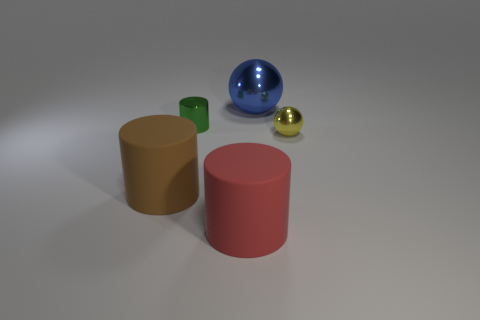Subtract all shiny cylinders. How many cylinders are left? 2 Subtract all cylinders. How many objects are left? 2 Add 3 small purple shiny blocks. How many objects exist? 8 Subtract 0 yellow blocks. How many objects are left? 5 Subtract all gray cylinders. Subtract all yellow blocks. How many cylinders are left? 3 Subtract all small things. Subtract all small blue matte spheres. How many objects are left? 3 Add 4 large matte things. How many large matte things are left? 6 Add 4 small yellow metal objects. How many small yellow metal objects exist? 5 